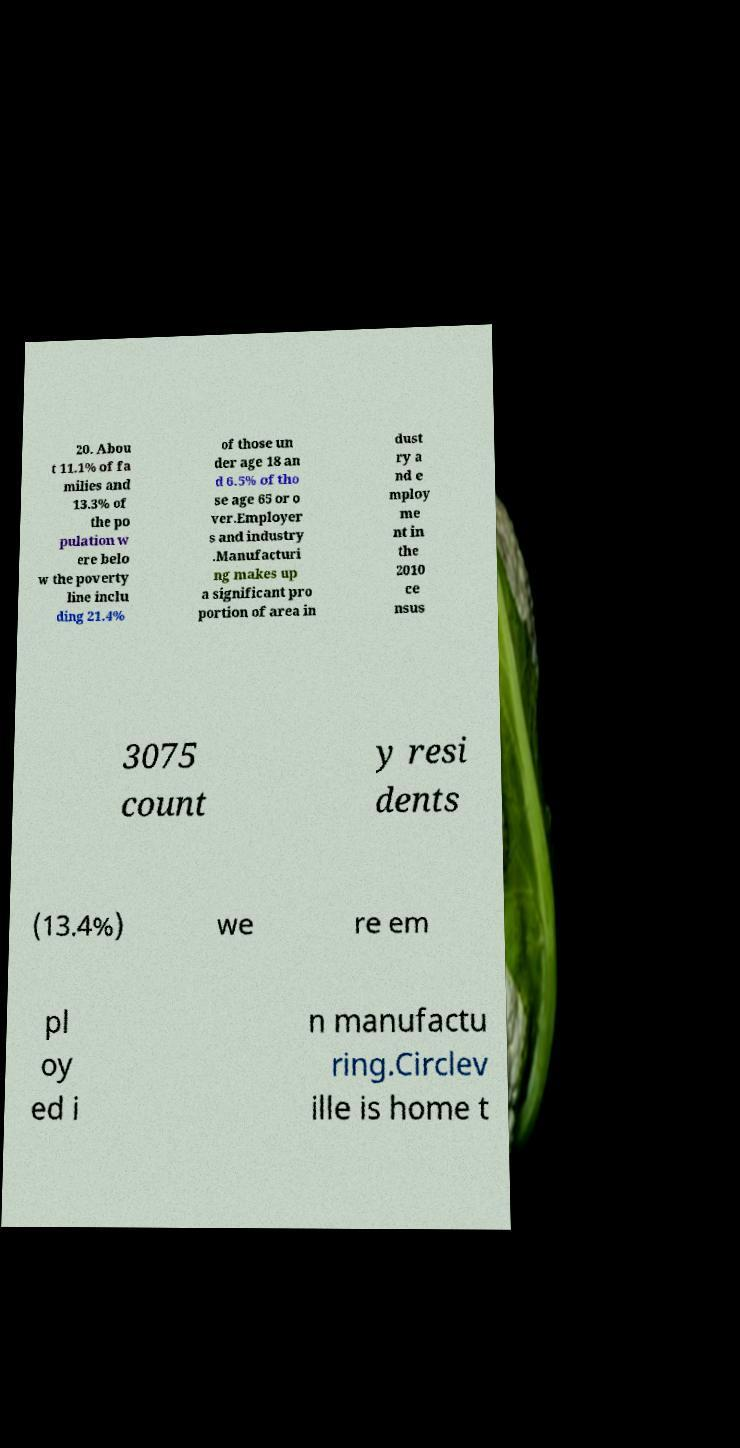What messages or text are displayed in this image? I need them in a readable, typed format. 20. Abou t 11.1% of fa milies and 13.3% of the po pulation w ere belo w the poverty line inclu ding 21.4% of those un der age 18 an d 6.5% of tho se age 65 or o ver.Employer s and industry .Manufacturi ng makes up a significant pro portion of area in dust ry a nd e mploy me nt in the 2010 ce nsus 3075 count y resi dents (13.4%) we re em pl oy ed i n manufactu ring.Circlev ille is home t 